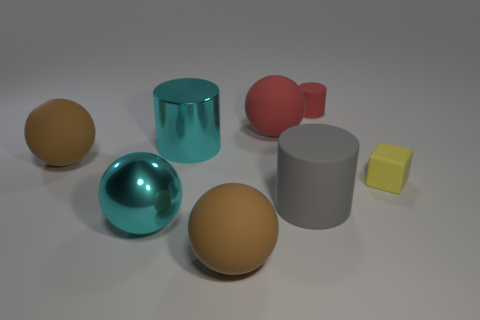Add 2 big yellow shiny cylinders. How many objects exist? 10 Subtract all cubes. How many objects are left? 7 Add 3 tiny red matte objects. How many tiny red matte objects exist? 4 Subtract 0 purple spheres. How many objects are left? 8 Subtract all yellow matte cubes. Subtract all red matte balls. How many objects are left? 6 Add 1 brown rubber things. How many brown rubber things are left? 3 